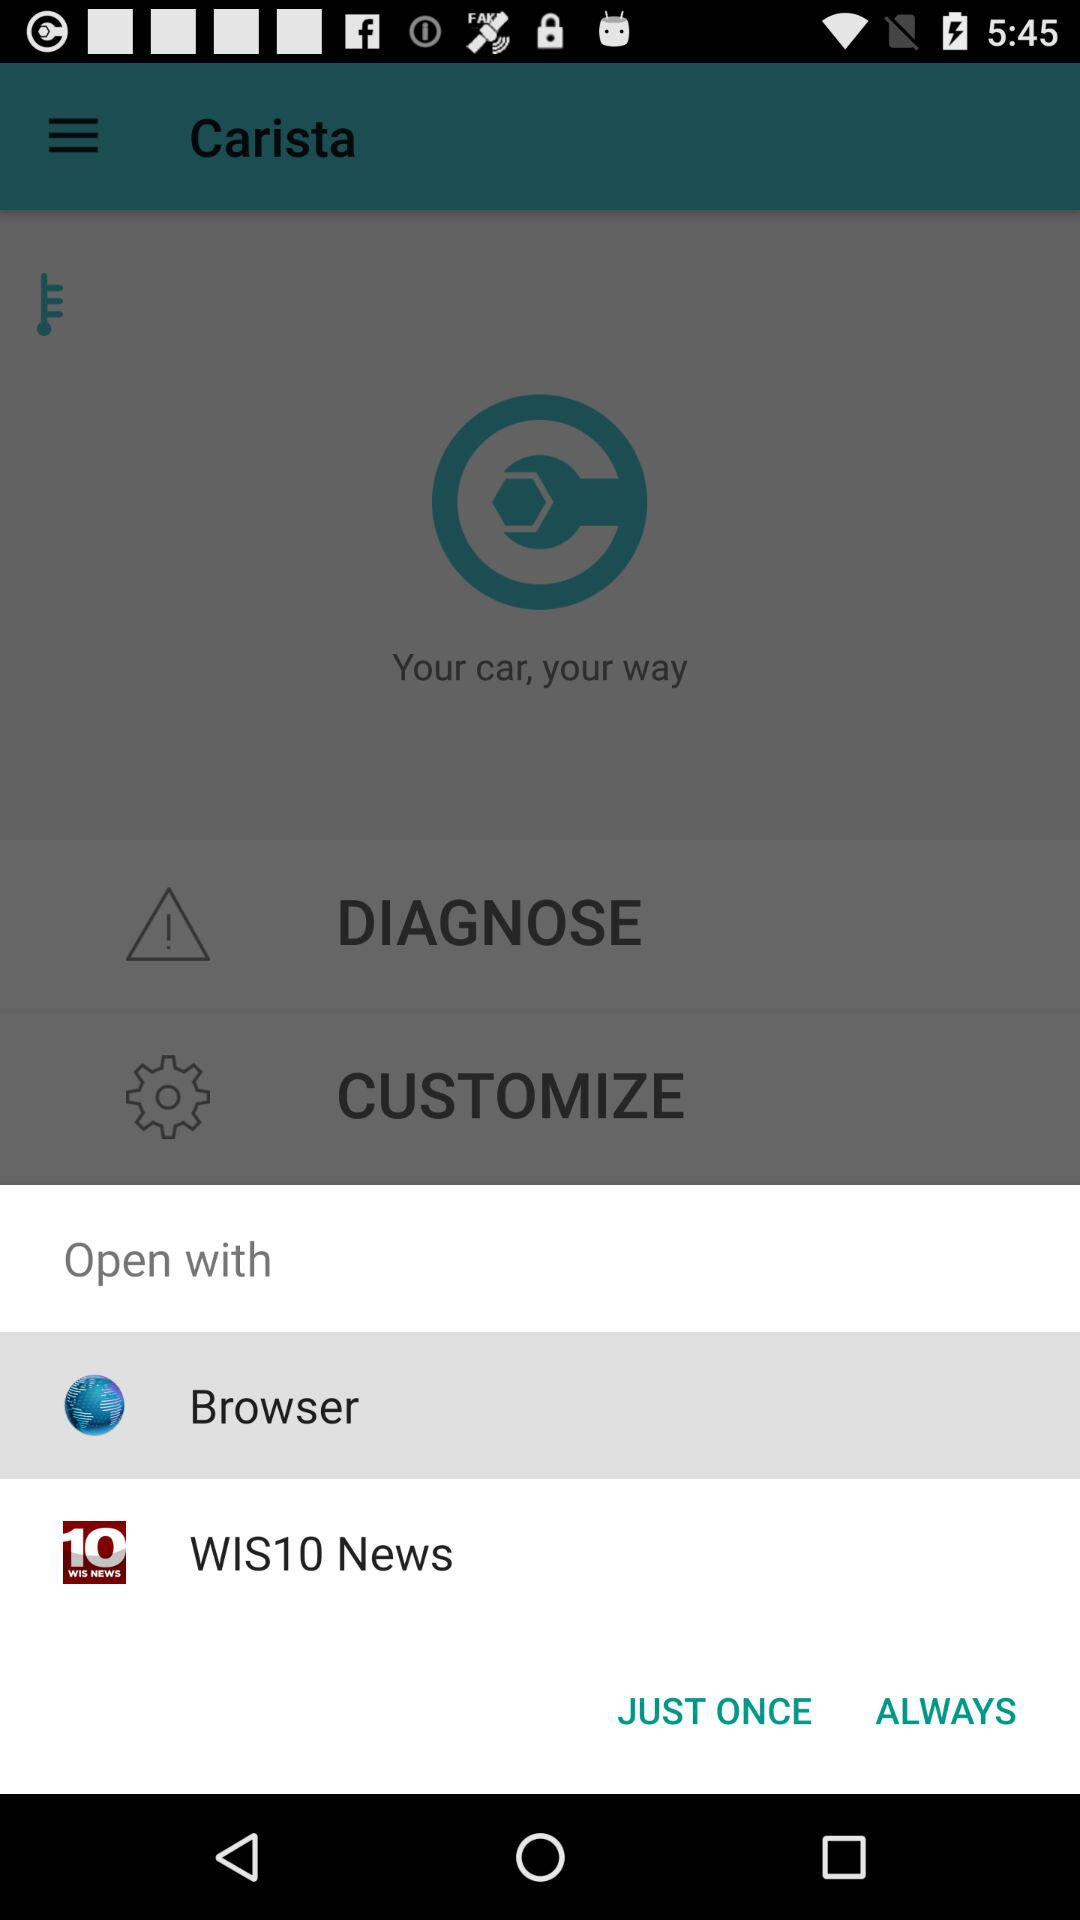What applications can I use to open the content? The applications are "Browser", and "WIS10 News". 